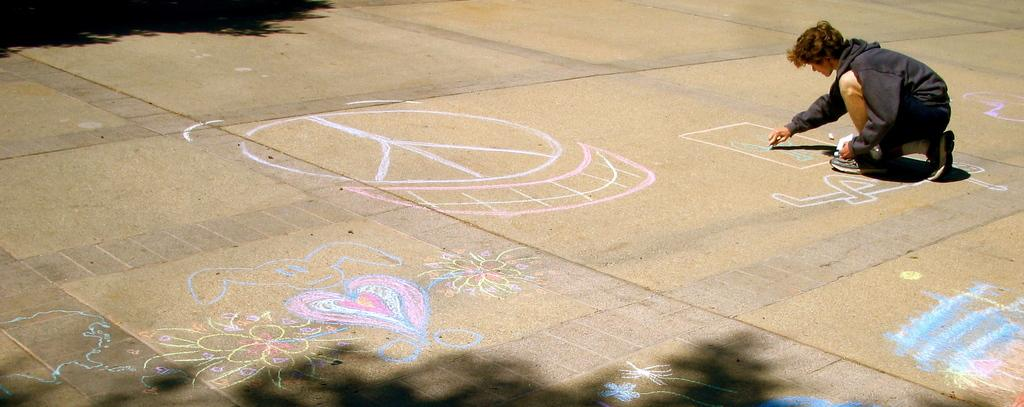Who is present in the image? There is a person in the image. What is the person doing in the image? The person is drawing on a road. What type of grain is being used by the person to draw on the road? There is no grain present in the image; the person is likely using chalk or another drawing material. 